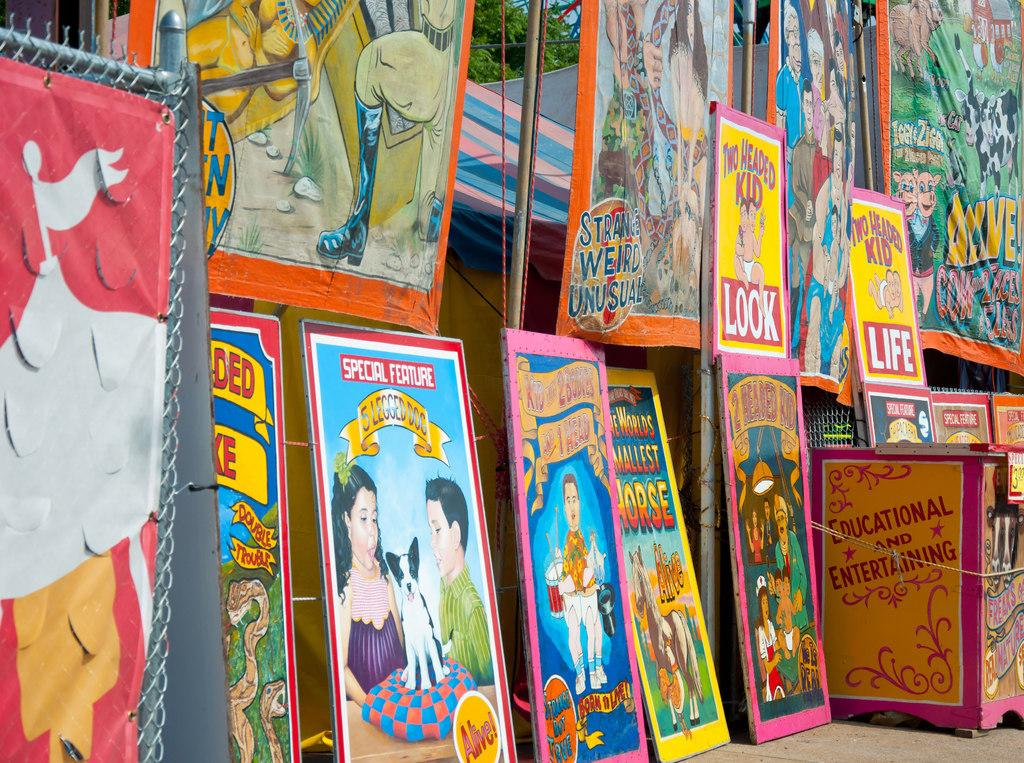<image>
Describe the image concisely. a collection of books with one being a special edition 5 leg dog book 